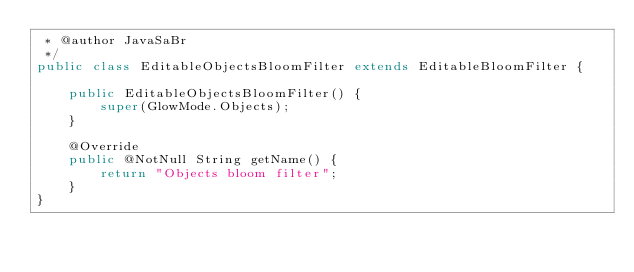Convert code to text. <code><loc_0><loc_0><loc_500><loc_500><_Java_> * @author JavaSaBr
 */
public class EditableObjectsBloomFilter extends EditableBloomFilter {

    public EditableObjectsBloomFilter() {
        super(GlowMode.Objects);
    }

    @Override
    public @NotNull String getName() {
        return "Objects bloom filter";
    }
}
</code> 